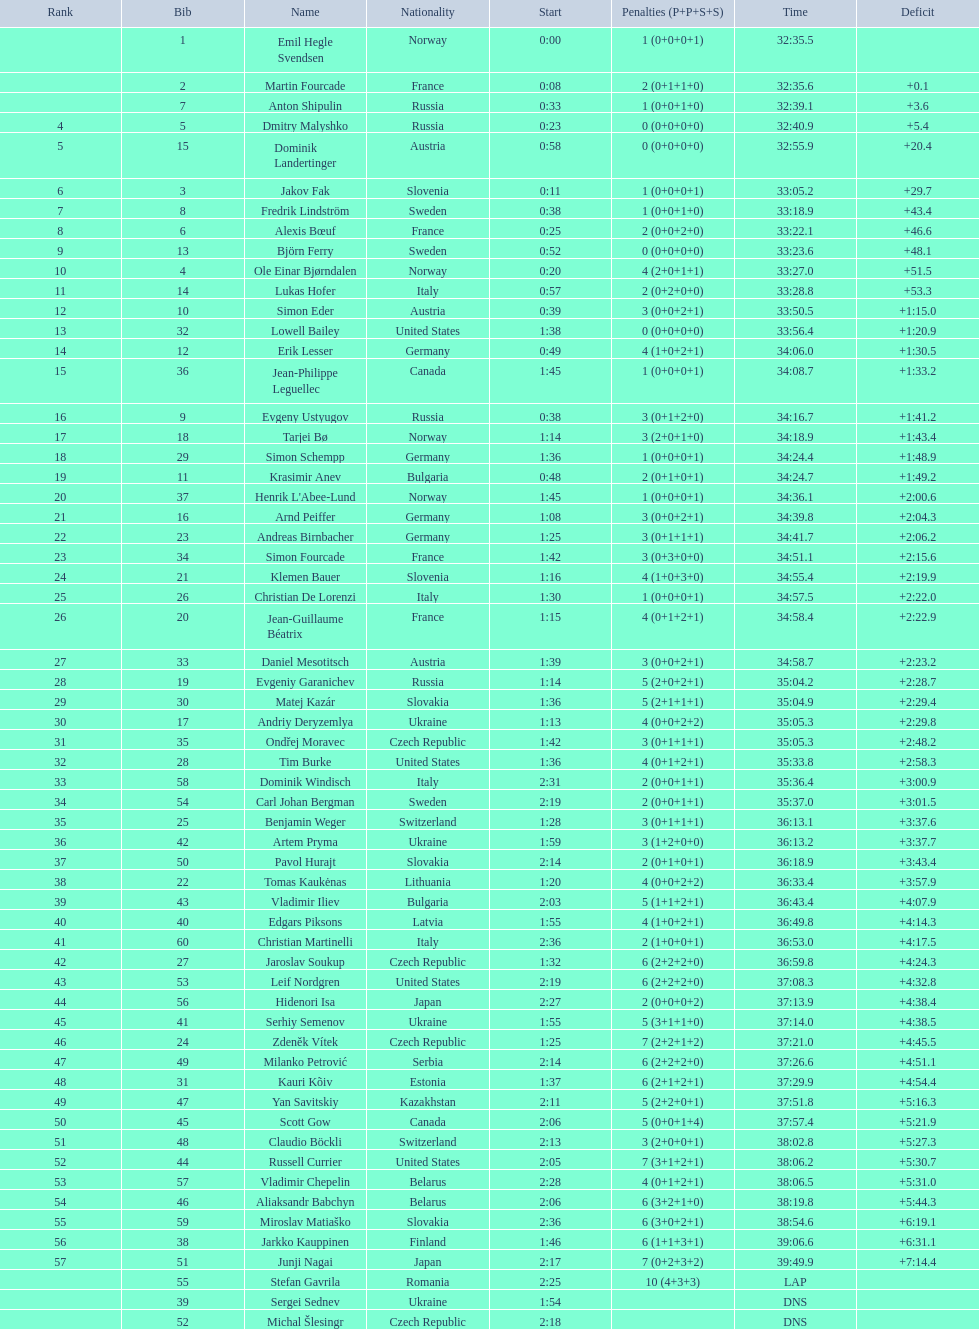What is the total number of participants between norway and france? 7. 